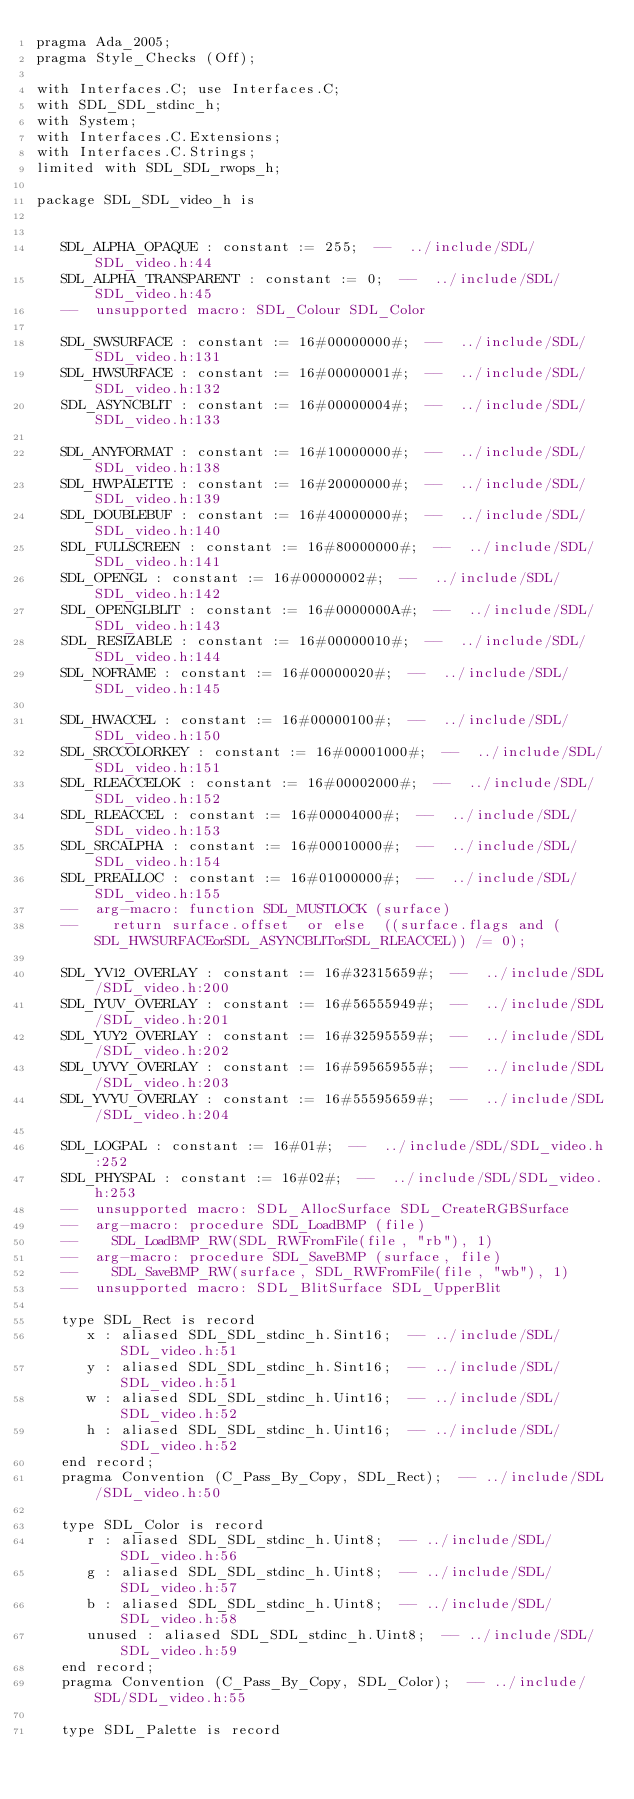<code> <loc_0><loc_0><loc_500><loc_500><_Ada_>pragma Ada_2005;
pragma Style_Checks (Off);

with Interfaces.C; use Interfaces.C;
with SDL_SDL_stdinc_h;
with System;
with Interfaces.C.Extensions;
with Interfaces.C.Strings;
limited with SDL_SDL_rwops_h;

package SDL_SDL_video_h is


   SDL_ALPHA_OPAQUE : constant := 255;  --  ../include/SDL/SDL_video.h:44
   SDL_ALPHA_TRANSPARENT : constant := 0;  --  ../include/SDL/SDL_video.h:45
   --  unsupported macro: SDL_Colour SDL_Color

   SDL_SWSURFACE : constant := 16#00000000#;  --  ../include/SDL/SDL_video.h:131
   SDL_HWSURFACE : constant := 16#00000001#;  --  ../include/SDL/SDL_video.h:132
   SDL_ASYNCBLIT : constant := 16#00000004#;  --  ../include/SDL/SDL_video.h:133

   SDL_ANYFORMAT : constant := 16#10000000#;  --  ../include/SDL/SDL_video.h:138
   SDL_HWPALETTE : constant := 16#20000000#;  --  ../include/SDL/SDL_video.h:139
   SDL_DOUBLEBUF : constant := 16#40000000#;  --  ../include/SDL/SDL_video.h:140
   SDL_FULLSCREEN : constant := 16#80000000#;  --  ../include/SDL/SDL_video.h:141
   SDL_OPENGL : constant := 16#00000002#;  --  ../include/SDL/SDL_video.h:142
   SDL_OPENGLBLIT : constant := 16#0000000A#;  --  ../include/SDL/SDL_video.h:143
   SDL_RESIZABLE : constant := 16#00000010#;  --  ../include/SDL/SDL_video.h:144
   SDL_NOFRAME : constant := 16#00000020#;  --  ../include/SDL/SDL_video.h:145

   SDL_HWACCEL : constant := 16#00000100#;  --  ../include/SDL/SDL_video.h:150
   SDL_SRCCOLORKEY : constant := 16#00001000#;  --  ../include/SDL/SDL_video.h:151
   SDL_RLEACCELOK : constant := 16#00002000#;  --  ../include/SDL/SDL_video.h:152
   SDL_RLEACCEL : constant := 16#00004000#;  --  ../include/SDL/SDL_video.h:153
   SDL_SRCALPHA : constant := 16#00010000#;  --  ../include/SDL/SDL_video.h:154
   SDL_PREALLOC : constant := 16#01000000#;  --  ../include/SDL/SDL_video.h:155
   --  arg-macro: function SDL_MUSTLOCK (surface)
   --    return surface.offset  or else  ((surface.flags and (SDL_HWSURFACEorSDL_ASYNCBLITorSDL_RLEACCEL)) /= 0);

   SDL_YV12_OVERLAY : constant := 16#32315659#;  --  ../include/SDL/SDL_video.h:200
   SDL_IYUV_OVERLAY : constant := 16#56555949#;  --  ../include/SDL/SDL_video.h:201
   SDL_YUY2_OVERLAY : constant := 16#32595559#;  --  ../include/SDL/SDL_video.h:202
   SDL_UYVY_OVERLAY : constant := 16#59565955#;  --  ../include/SDL/SDL_video.h:203
   SDL_YVYU_OVERLAY : constant := 16#55595659#;  --  ../include/SDL/SDL_video.h:204

   SDL_LOGPAL : constant := 16#01#;  --  ../include/SDL/SDL_video.h:252
   SDL_PHYSPAL : constant := 16#02#;  --  ../include/SDL/SDL_video.h:253
   --  unsupported macro: SDL_AllocSurface SDL_CreateRGBSurface
   --  arg-macro: procedure SDL_LoadBMP (file)
   --    SDL_LoadBMP_RW(SDL_RWFromFile(file, "rb"), 1)
   --  arg-macro: procedure SDL_SaveBMP (surface, file)
   --    SDL_SaveBMP_RW(surface, SDL_RWFromFile(file, "wb"), 1)
   --  unsupported macro: SDL_BlitSurface SDL_UpperBlit

   type SDL_Rect is record
      x : aliased SDL_SDL_stdinc_h.Sint16;  -- ../include/SDL/SDL_video.h:51
      y : aliased SDL_SDL_stdinc_h.Sint16;  -- ../include/SDL/SDL_video.h:51
      w : aliased SDL_SDL_stdinc_h.Uint16;  -- ../include/SDL/SDL_video.h:52
      h : aliased SDL_SDL_stdinc_h.Uint16;  -- ../include/SDL/SDL_video.h:52
   end record;
   pragma Convention (C_Pass_By_Copy, SDL_Rect);  -- ../include/SDL/SDL_video.h:50

   type SDL_Color is record
      r : aliased SDL_SDL_stdinc_h.Uint8;  -- ../include/SDL/SDL_video.h:56
      g : aliased SDL_SDL_stdinc_h.Uint8;  -- ../include/SDL/SDL_video.h:57
      b : aliased SDL_SDL_stdinc_h.Uint8;  -- ../include/SDL/SDL_video.h:58
      unused : aliased SDL_SDL_stdinc_h.Uint8;  -- ../include/SDL/SDL_video.h:59
   end record;
   pragma Convention (C_Pass_By_Copy, SDL_Color);  -- ../include/SDL/SDL_video.h:55

   type SDL_Palette is record</code> 